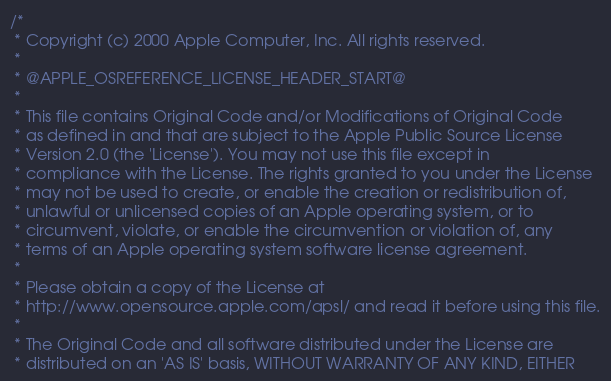<code> <loc_0><loc_0><loc_500><loc_500><_C_>/*
 * Copyright (c) 2000 Apple Computer, Inc. All rights reserved.
 *
 * @APPLE_OSREFERENCE_LICENSE_HEADER_START@
 * 
 * This file contains Original Code and/or Modifications of Original Code
 * as defined in and that are subject to the Apple Public Source License
 * Version 2.0 (the 'License'). You may not use this file except in
 * compliance with the License. The rights granted to you under the License
 * may not be used to create, or enable the creation or redistribution of,
 * unlawful or unlicensed copies of an Apple operating system, or to
 * circumvent, violate, or enable the circumvention or violation of, any
 * terms of an Apple operating system software license agreement.
 * 
 * Please obtain a copy of the License at
 * http://www.opensource.apple.com/apsl/ and read it before using this file.
 * 
 * The Original Code and all software distributed under the License are
 * distributed on an 'AS IS' basis, WITHOUT WARRANTY OF ANY KIND, EITHER</code> 